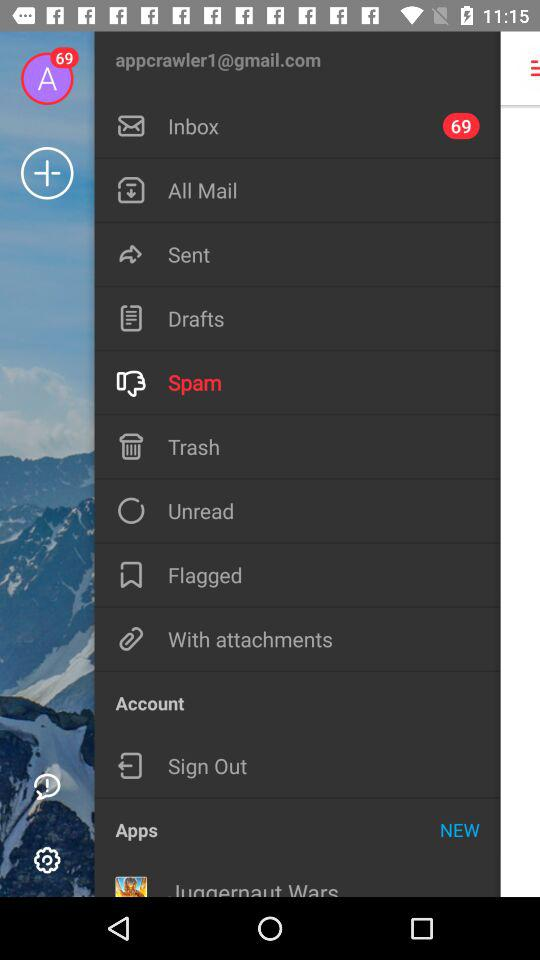What is the email address? The email address is appcrawler1@gmail.com. 